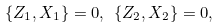Convert formula to latex. <formula><loc_0><loc_0><loc_500><loc_500>\{ Z _ { 1 } , X _ { 1 } \} = 0 , \ & \{ Z _ { 2 } , X _ { 2 } \} = 0 , \\</formula> 